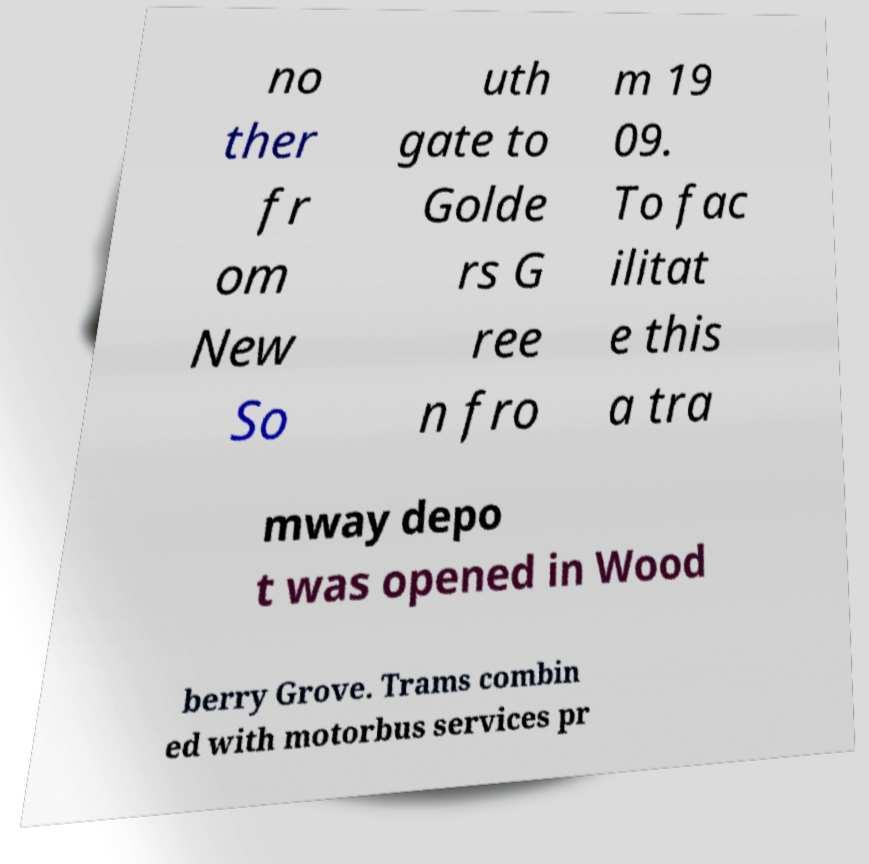Please identify and transcribe the text found in this image. no ther fr om New So uth gate to Golde rs G ree n fro m 19 09. To fac ilitat e this a tra mway depo t was opened in Wood berry Grove. Trams combin ed with motorbus services pr 